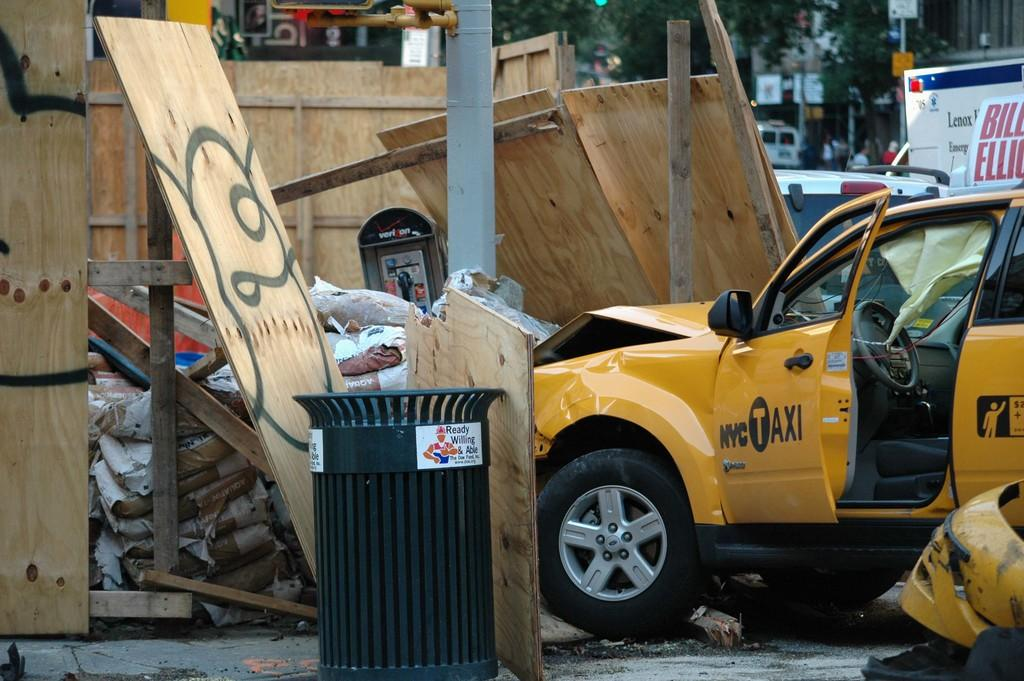<image>
Share a concise interpretation of the image provided. a yellow car that has NYC on it 